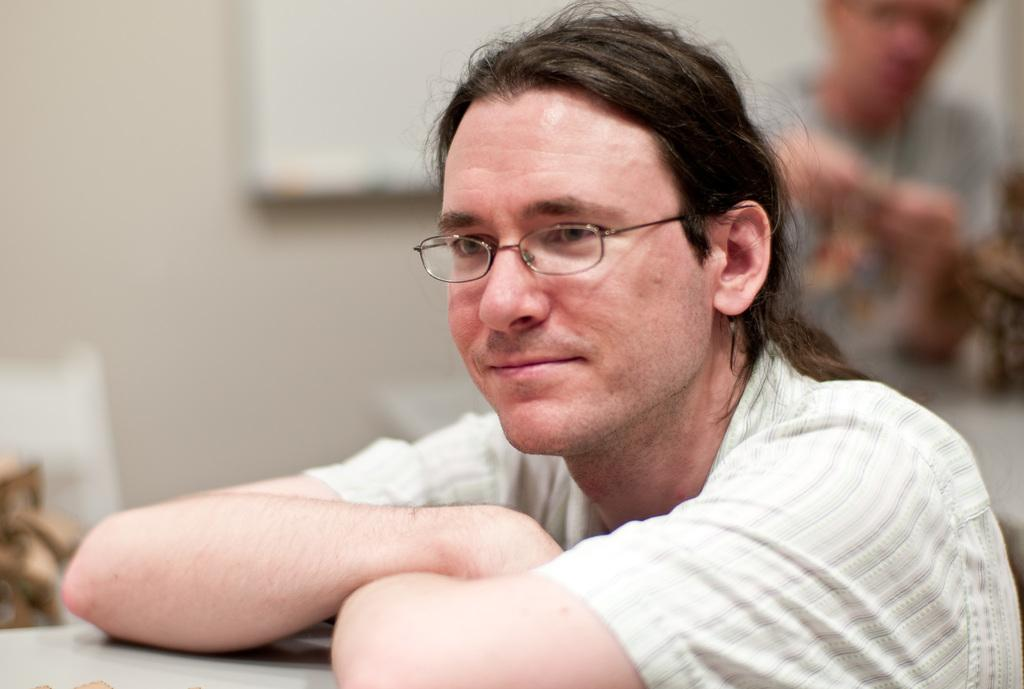What is the gender of the person in the image? The person in the image is a man. What is the position of the person in the image? There is a person sitting in the image. What is visible in the background of the image? There is a wall visible in the image. What type of acoustics can be heard in the image? There is no information about any sounds or acoustics in the image. What nation does the man in the image belong to? There is no information about the man's nationality in the image. 